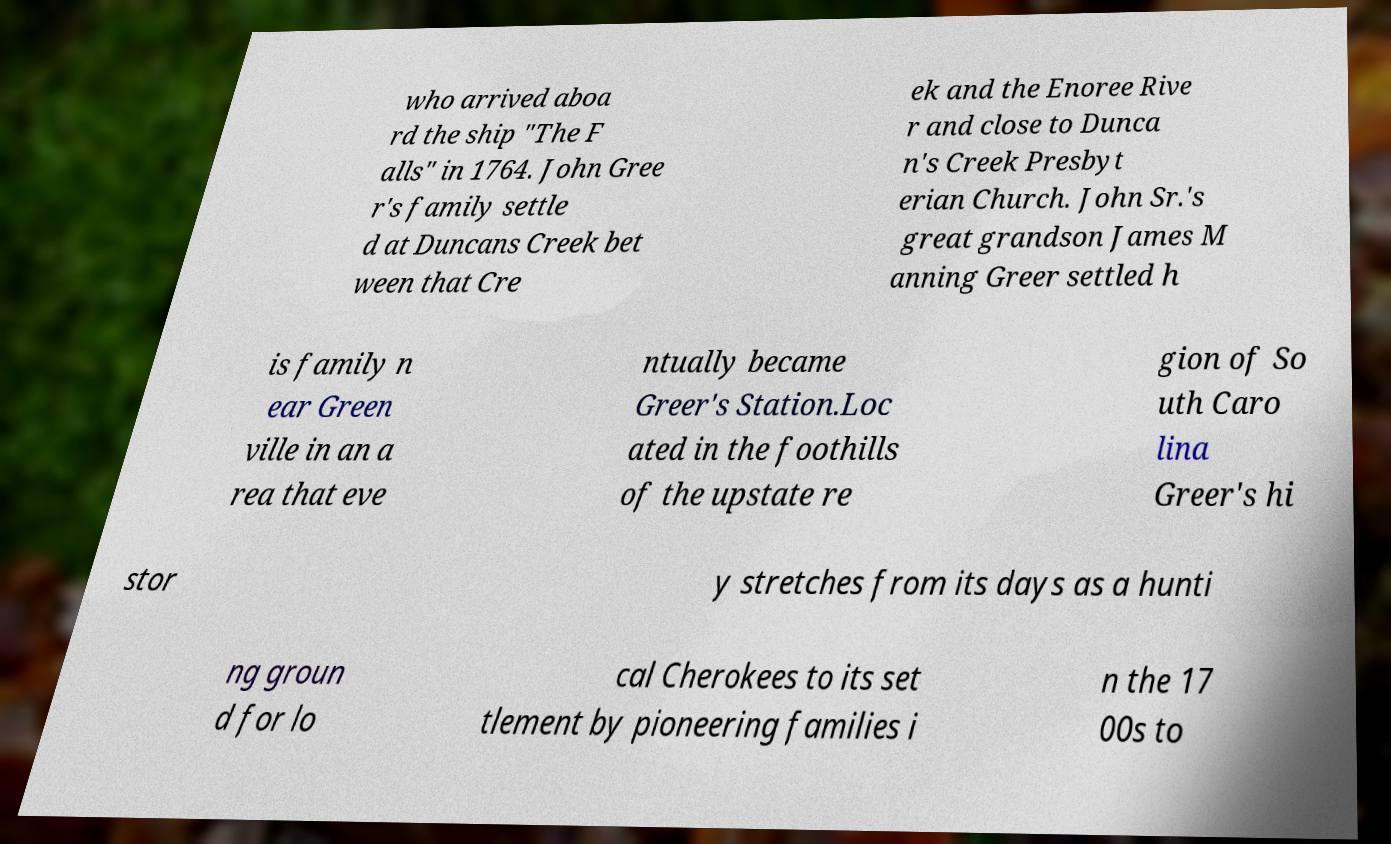Please identify and transcribe the text found in this image. who arrived aboa rd the ship "The F alls" in 1764. John Gree r's family settle d at Duncans Creek bet ween that Cre ek and the Enoree Rive r and close to Dunca n's Creek Presbyt erian Church. John Sr.'s great grandson James M anning Greer settled h is family n ear Green ville in an a rea that eve ntually became Greer's Station.Loc ated in the foothills of the upstate re gion of So uth Caro lina Greer's hi stor y stretches from its days as a hunti ng groun d for lo cal Cherokees to its set tlement by pioneering families i n the 17 00s to 